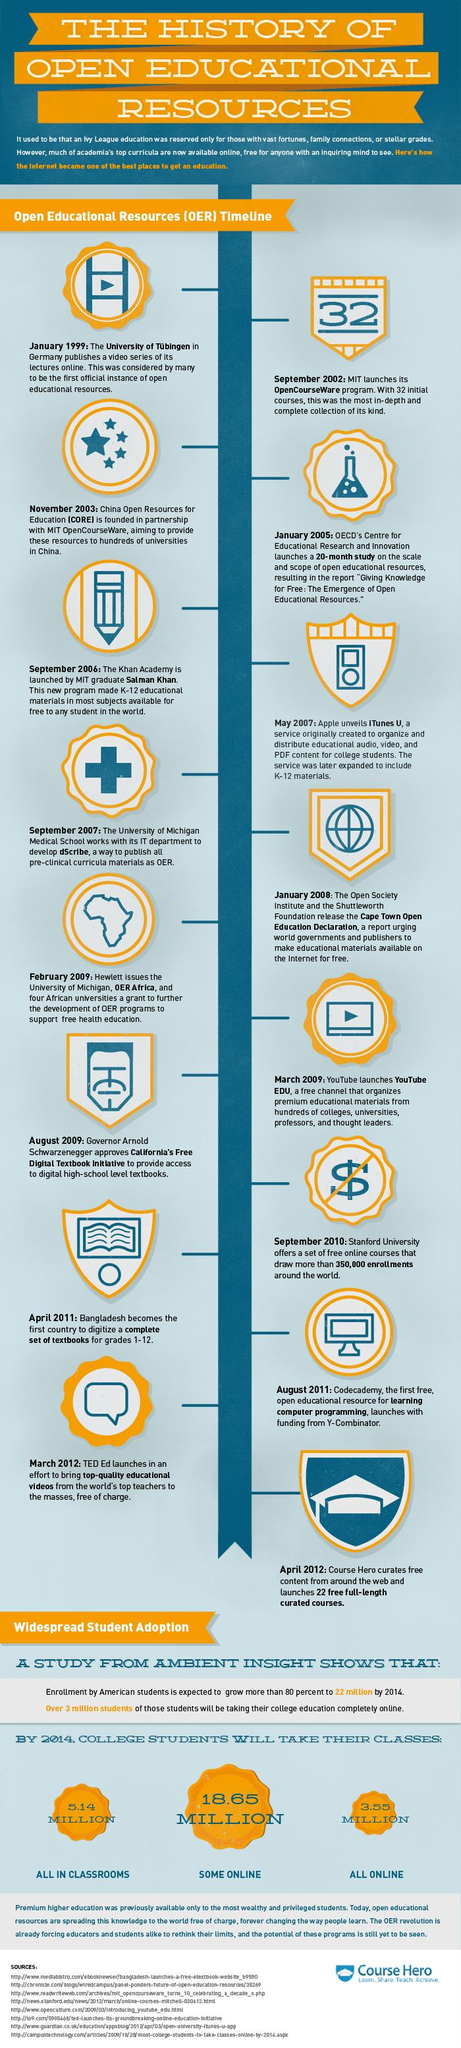Mention a couple of crucial points in this snapshot. Eight sources are listed at the bottom. 